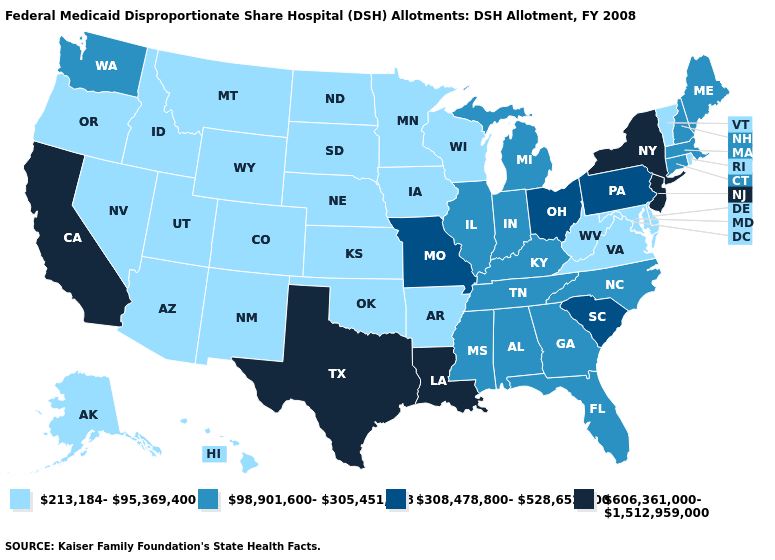Name the states that have a value in the range 213,184-95,369,400?
Answer briefly. Alaska, Arizona, Arkansas, Colorado, Delaware, Hawaii, Idaho, Iowa, Kansas, Maryland, Minnesota, Montana, Nebraska, Nevada, New Mexico, North Dakota, Oklahoma, Oregon, Rhode Island, South Dakota, Utah, Vermont, Virginia, West Virginia, Wisconsin, Wyoming. Among the states that border Michigan , which have the lowest value?
Be succinct. Wisconsin. Which states hav the highest value in the Northeast?
Concise answer only. New Jersey, New York. Does Kentucky have the highest value in the USA?
Quick response, please. No. Among the states that border Michigan , does Ohio have the lowest value?
Be succinct. No. What is the value of Washington?
Write a very short answer. 98,901,600-305,451,928. Does Alabama have a higher value than Georgia?
Keep it brief. No. Which states have the lowest value in the Northeast?
Concise answer only. Rhode Island, Vermont. What is the lowest value in states that border Ohio?
Keep it brief. 213,184-95,369,400. What is the value of Pennsylvania?
Be succinct. 308,478,800-528,652,600. What is the highest value in states that border Illinois?
Give a very brief answer. 308,478,800-528,652,600. Does Utah have the highest value in the West?
Quick response, please. No. Does Missouri have the highest value in the MidWest?
Be succinct. Yes. What is the lowest value in the USA?
Write a very short answer. 213,184-95,369,400. What is the highest value in the MidWest ?
Quick response, please. 308,478,800-528,652,600. 